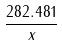Convert formula to latex. <formula><loc_0><loc_0><loc_500><loc_500>\frac { 2 8 2 . 4 8 1 } { x }</formula> 